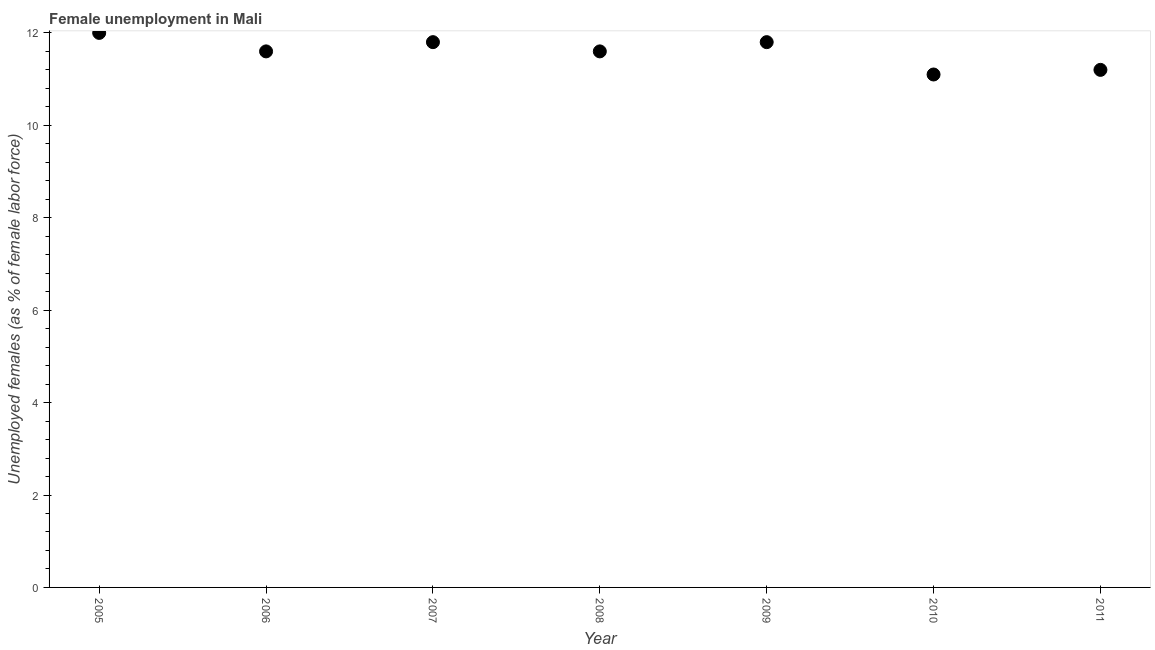Across all years, what is the minimum unemployed females population?
Make the answer very short. 11.1. In which year was the unemployed females population minimum?
Ensure brevity in your answer.  2010. What is the sum of the unemployed females population?
Give a very brief answer. 81.1. What is the difference between the unemployed females population in 2008 and 2010?
Make the answer very short. 0.5. What is the average unemployed females population per year?
Make the answer very short. 11.59. What is the median unemployed females population?
Your answer should be very brief. 11.6. In how many years, is the unemployed females population greater than 11.6 %?
Keep it short and to the point. 5. Do a majority of the years between 2011 and 2010 (inclusive) have unemployed females population greater than 7.6 %?
Your answer should be compact. No. Is the unemployed females population in 2007 less than that in 2011?
Make the answer very short. No. Is the difference between the unemployed females population in 2007 and 2008 greater than the difference between any two years?
Offer a terse response. No. What is the difference between the highest and the second highest unemployed females population?
Make the answer very short. 0.2. What is the difference between the highest and the lowest unemployed females population?
Provide a short and direct response. 0.9. In how many years, is the unemployed females population greater than the average unemployed females population taken over all years?
Ensure brevity in your answer.  5. Does the unemployed females population monotonically increase over the years?
Provide a succinct answer. No. How many years are there in the graph?
Provide a succinct answer. 7. Are the values on the major ticks of Y-axis written in scientific E-notation?
Ensure brevity in your answer.  No. Does the graph contain any zero values?
Your answer should be very brief. No. What is the title of the graph?
Give a very brief answer. Female unemployment in Mali. What is the label or title of the Y-axis?
Provide a succinct answer. Unemployed females (as % of female labor force). What is the Unemployed females (as % of female labor force) in 2006?
Provide a succinct answer. 11.6. What is the Unemployed females (as % of female labor force) in 2007?
Your answer should be very brief. 11.8. What is the Unemployed females (as % of female labor force) in 2008?
Keep it short and to the point. 11.6. What is the Unemployed females (as % of female labor force) in 2009?
Offer a terse response. 11.8. What is the Unemployed females (as % of female labor force) in 2010?
Your response must be concise. 11.1. What is the Unemployed females (as % of female labor force) in 2011?
Offer a terse response. 11.2. What is the difference between the Unemployed females (as % of female labor force) in 2005 and 2008?
Ensure brevity in your answer.  0.4. What is the difference between the Unemployed females (as % of female labor force) in 2005 and 2011?
Your answer should be compact. 0.8. What is the difference between the Unemployed females (as % of female labor force) in 2006 and 2007?
Offer a terse response. -0.2. What is the difference between the Unemployed females (as % of female labor force) in 2006 and 2009?
Your response must be concise. -0.2. What is the difference between the Unemployed females (as % of female labor force) in 2007 and 2009?
Give a very brief answer. 0. What is the difference between the Unemployed females (as % of female labor force) in 2007 and 2010?
Provide a short and direct response. 0.7. What is the difference between the Unemployed females (as % of female labor force) in 2008 and 2009?
Your response must be concise. -0.2. What is the difference between the Unemployed females (as % of female labor force) in 2009 and 2010?
Make the answer very short. 0.7. What is the difference between the Unemployed females (as % of female labor force) in 2009 and 2011?
Provide a succinct answer. 0.6. What is the ratio of the Unemployed females (as % of female labor force) in 2005 to that in 2006?
Keep it short and to the point. 1.03. What is the ratio of the Unemployed females (as % of female labor force) in 2005 to that in 2008?
Make the answer very short. 1.03. What is the ratio of the Unemployed females (as % of female labor force) in 2005 to that in 2009?
Offer a terse response. 1.02. What is the ratio of the Unemployed females (as % of female labor force) in 2005 to that in 2010?
Offer a very short reply. 1.08. What is the ratio of the Unemployed females (as % of female labor force) in 2005 to that in 2011?
Keep it short and to the point. 1.07. What is the ratio of the Unemployed females (as % of female labor force) in 2006 to that in 2007?
Offer a terse response. 0.98. What is the ratio of the Unemployed females (as % of female labor force) in 2006 to that in 2008?
Your answer should be compact. 1. What is the ratio of the Unemployed females (as % of female labor force) in 2006 to that in 2009?
Give a very brief answer. 0.98. What is the ratio of the Unemployed females (as % of female labor force) in 2006 to that in 2010?
Ensure brevity in your answer.  1.04. What is the ratio of the Unemployed females (as % of female labor force) in 2006 to that in 2011?
Make the answer very short. 1.04. What is the ratio of the Unemployed females (as % of female labor force) in 2007 to that in 2008?
Offer a terse response. 1.02. What is the ratio of the Unemployed females (as % of female labor force) in 2007 to that in 2009?
Offer a terse response. 1. What is the ratio of the Unemployed females (as % of female labor force) in 2007 to that in 2010?
Keep it short and to the point. 1.06. What is the ratio of the Unemployed females (as % of female labor force) in 2007 to that in 2011?
Your answer should be compact. 1.05. What is the ratio of the Unemployed females (as % of female labor force) in 2008 to that in 2009?
Provide a succinct answer. 0.98. What is the ratio of the Unemployed females (as % of female labor force) in 2008 to that in 2010?
Your answer should be very brief. 1.04. What is the ratio of the Unemployed females (as % of female labor force) in 2008 to that in 2011?
Provide a succinct answer. 1.04. What is the ratio of the Unemployed females (as % of female labor force) in 2009 to that in 2010?
Your answer should be very brief. 1.06. What is the ratio of the Unemployed females (as % of female labor force) in 2009 to that in 2011?
Provide a succinct answer. 1.05. What is the ratio of the Unemployed females (as % of female labor force) in 2010 to that in 2011?
Your answer should be compact. 0.99. 